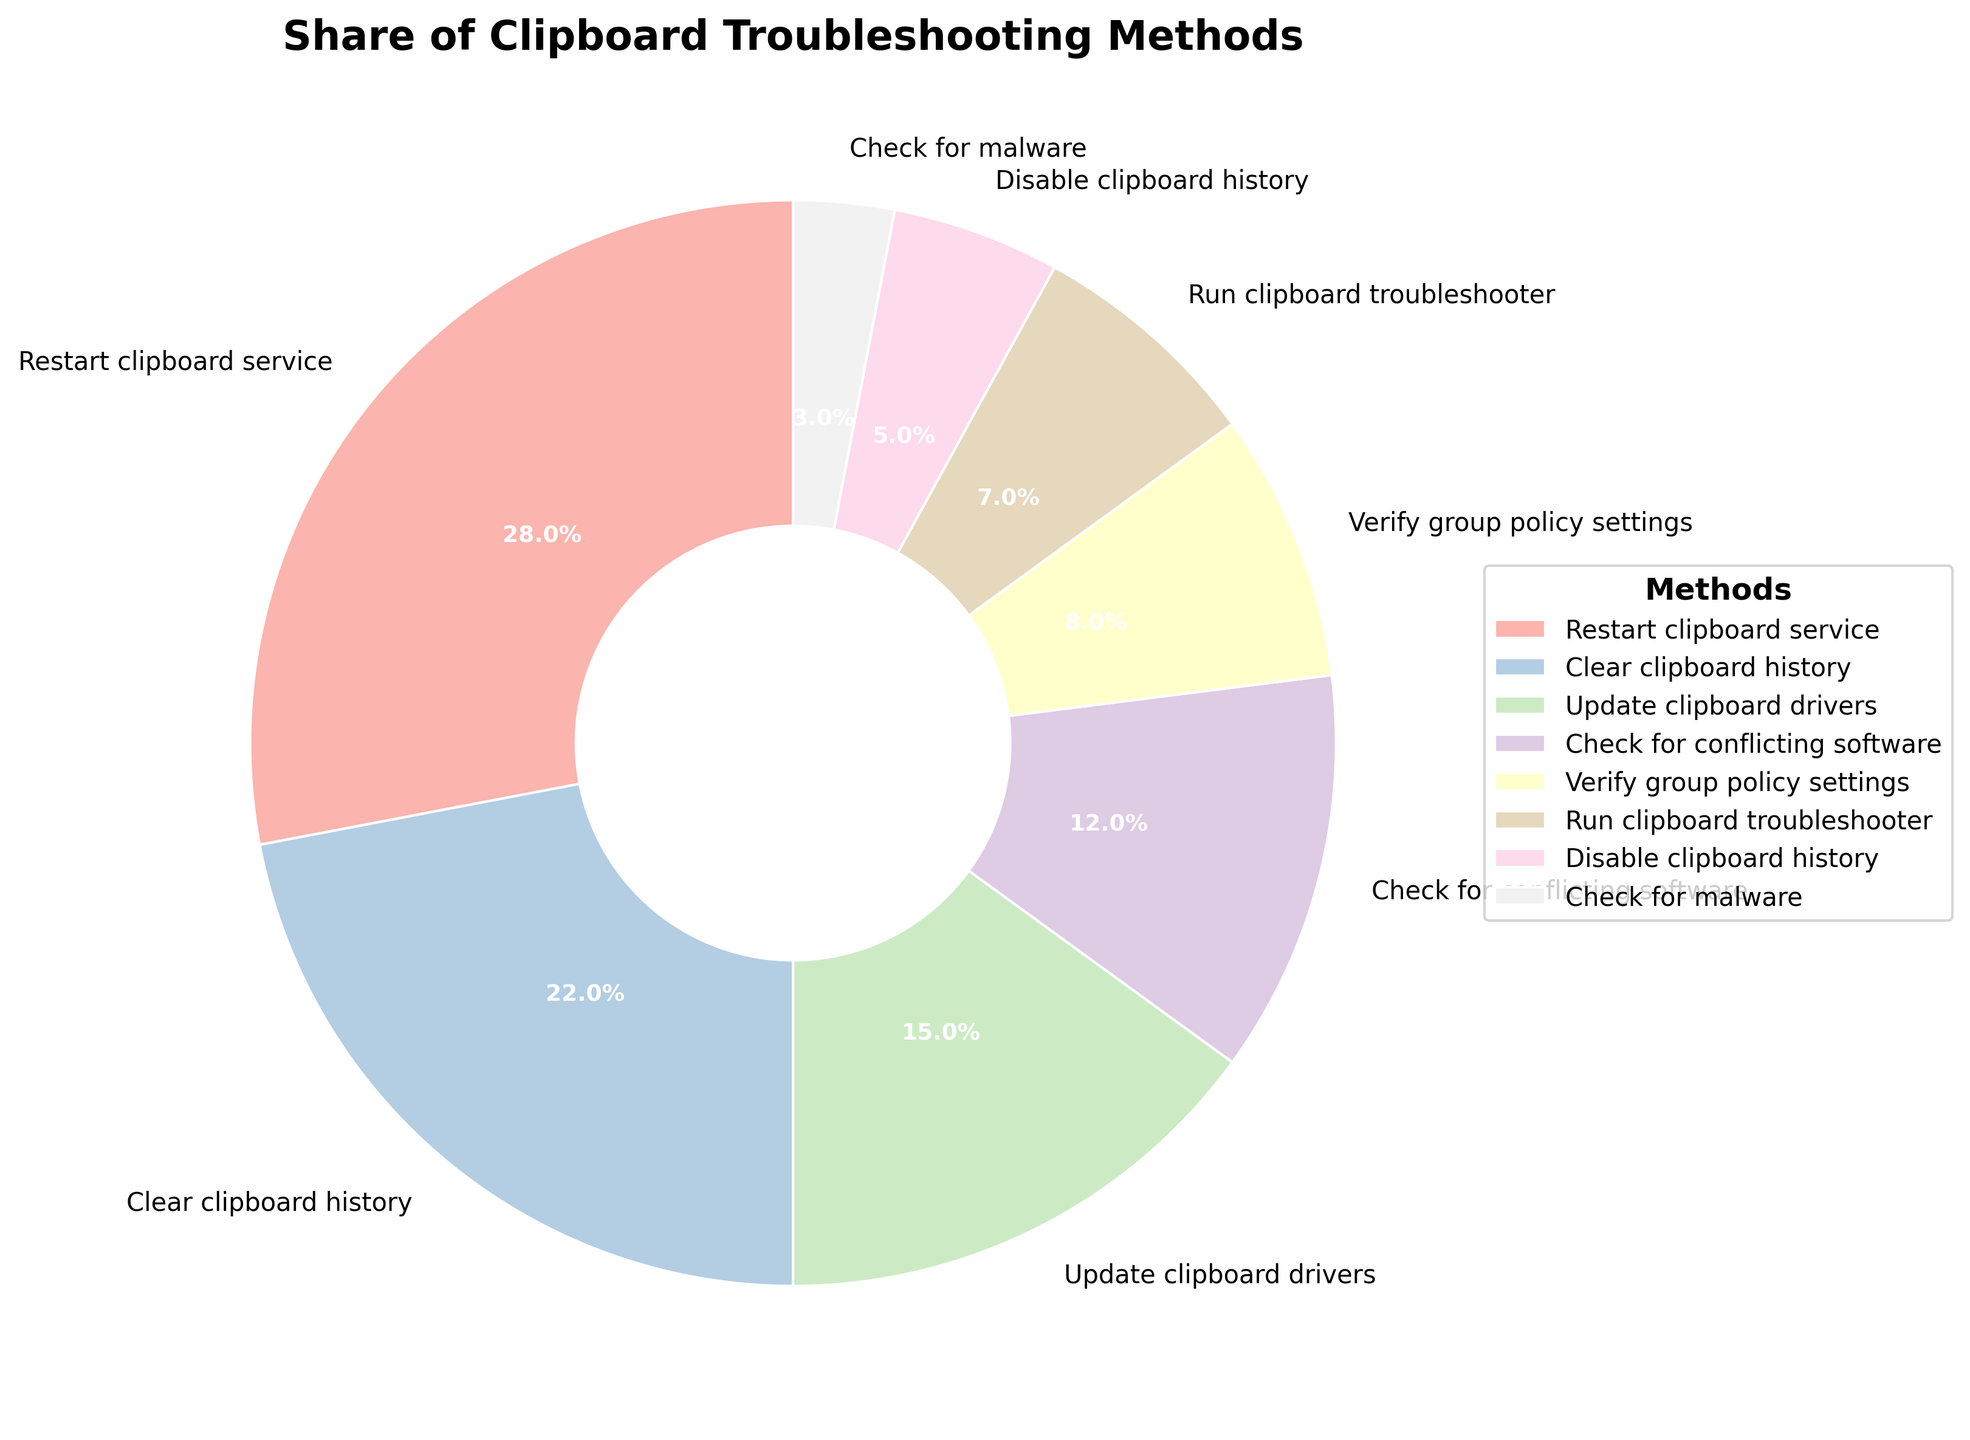Which method has the highest share of use? The largest segment on the pie chart represents the method with the highest percentage. The "Restart clipboard service" segment is the largest, indicating it has the highest share.
Answer: Restart clipboard service Which troubleshooting method is the least used? The smallest segment on the pie chart represents the least used method. The "Check for malware" segment is the smallest, showing it is the least used.
Answer: Check for malware What is the combined percentage of the two most used troubleshooting methods? Adding the percentages of the top two methods: "Restart clipboard service" (28%) and "Clear clipboard history" (22%) gives a total of 28 + 22 = 50%.
Answer: 50% Which method has a greater share: "Check for conflicting software" or "Update clipboard drivers"? By comparing the percentages in the pie chart, "Update clipboard drivers" has 15%, while "Check for conflicting software" has 12%, indicating "Update clipboard drivers" has a greater share.
Answer: Update clipboard drivers How much more frequently is "Verify group policy settings" used compared to "Disable clipboard history"? Subtract the percentage of "Disable clipboard history" (5%) from "Verify group policy settings" (8%), resulting in 8 - 5 = 3%.
Answer: 3% What is the average percentage of the methods excluding the least used one? Excluding the least used method ("Check for malware" with 3%), sum the remaining percentages: 28 + 22 + 15 + 12 + 8 + 7 + 5 = 97. Divide by the number of remaining methods (7): 97 / 7 ≈ 13.86%.
Answer: 13.86% How do the shares of "Run clipboard troubleshooter" and "Check for conflicting software" compare? "Run clipboard troubleshooter" has a share of 7%, while "Check for conflicting software" has 12%. By comparing these percentages, "Check for conflicting software" has a higher share.
Answer: Check for conflicting software By what factor is the share of "Restart clipboard service" larger than that of "Check for malware"? Divide the percentage of "Restart clipboard service" (28%) by "Check for malware" (3%), resulting in 28 / 3 ≈ 9.33.
Answer: 9.33 What is the total share percentage of methods that have less than a 10% share each? Sum the percentages of methods with less than 10%: "Verify group policy settings" (8%), "Run clipboard troubleshooter" (7%), "Disable clipboard history" (5%), "Check for malware" (3%). The total is 8 + 7 + 5 + 3 = 23%.
Answer: 23% 